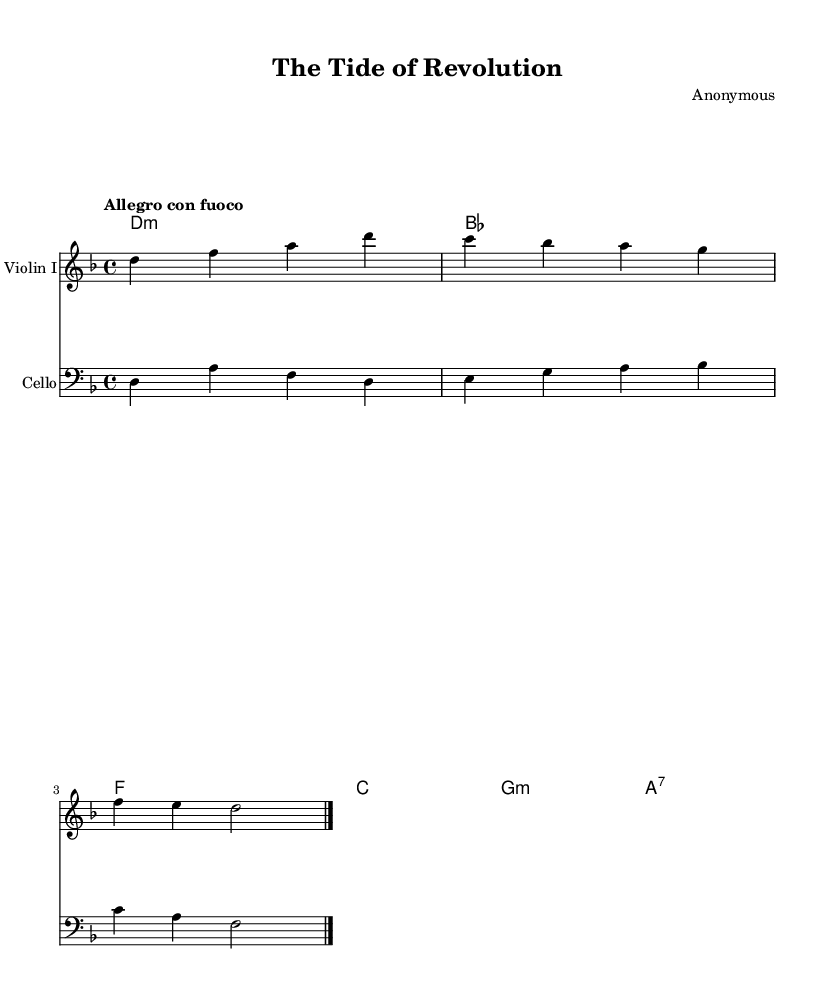What is the key signature of this music? The key signature is shown at the beginning of the staff, indicating D minor, which has one flat (B flat).
Answer: D minor What is the time signature of this music? The time signature is located at the beginning of the score and indicates 4/4 time, meaning there are four beats in each measure.
Answer: 4/4 What is the tempo marking for this piece? The tempo marking is indicated at the beginning with "Allegro con fuoco," suggesting a fast tempo with fiery character.
Answer: Allegro con fuoco How many measures are in the provided music? By counting the distinct sections divided by the bar lines, there are two measures for the violin I part and two measures for the cello part, leading to a total of two combined measures presented in the score.
Answer: 2 What is the harmonic structure at the beginning of the piece? The harmonic structure is represented using chord symbols and indicates D minor, B flat major, F major, C major, G minor, and A7, which create a progression typical for Romantic music.
Answer: D minor, B flat, F, C, G minor, A7 What does the term "Allegro con fuoco" suggest about the character of the music? The term indicates that the music should be played quickly ("Allegro") and with fire or passion ("con fuoco"), reflecting the dramatic and emotive tendencies often found in Romantic compositions.
Answer: Passionate 